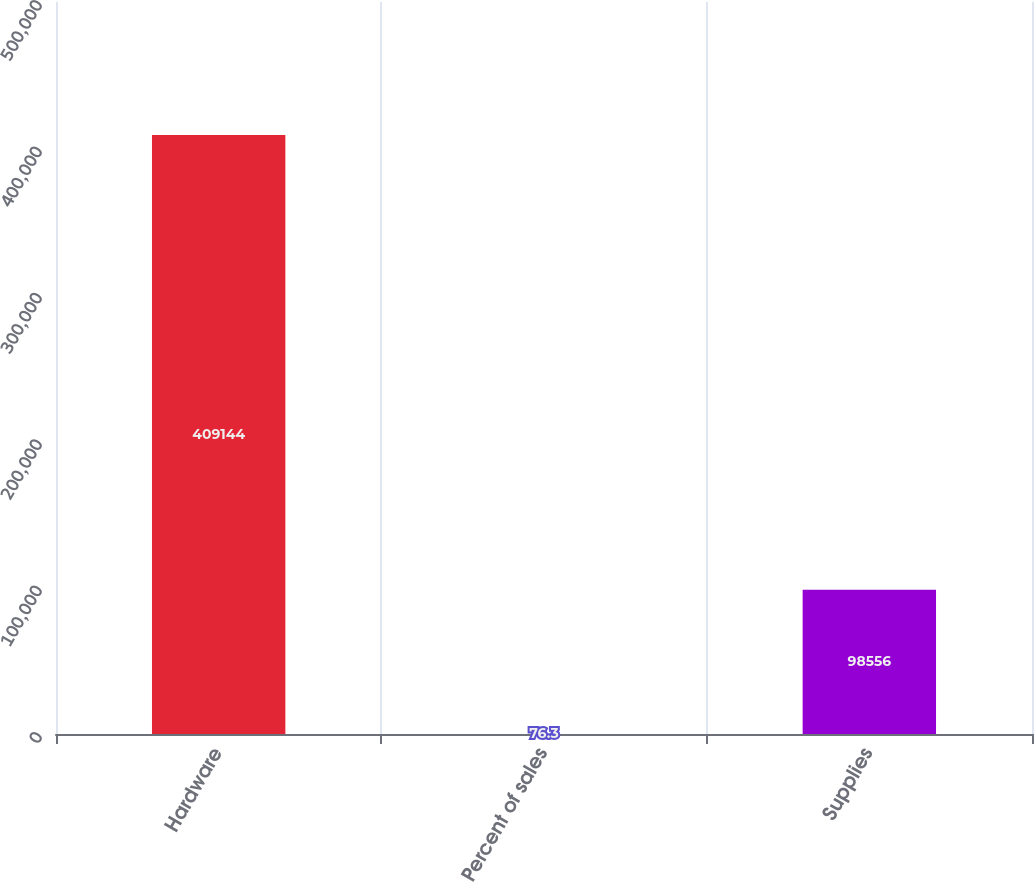Convert chart to OTSL. <chart><loc_0><loc_0><loc_500><loc_500><bar_chart><fcel>Hardware<fcel>Percent of sales<fcel>Supplies<nl><fcel>409144<fcel>76.3<fcel>98556<nl></chart> 